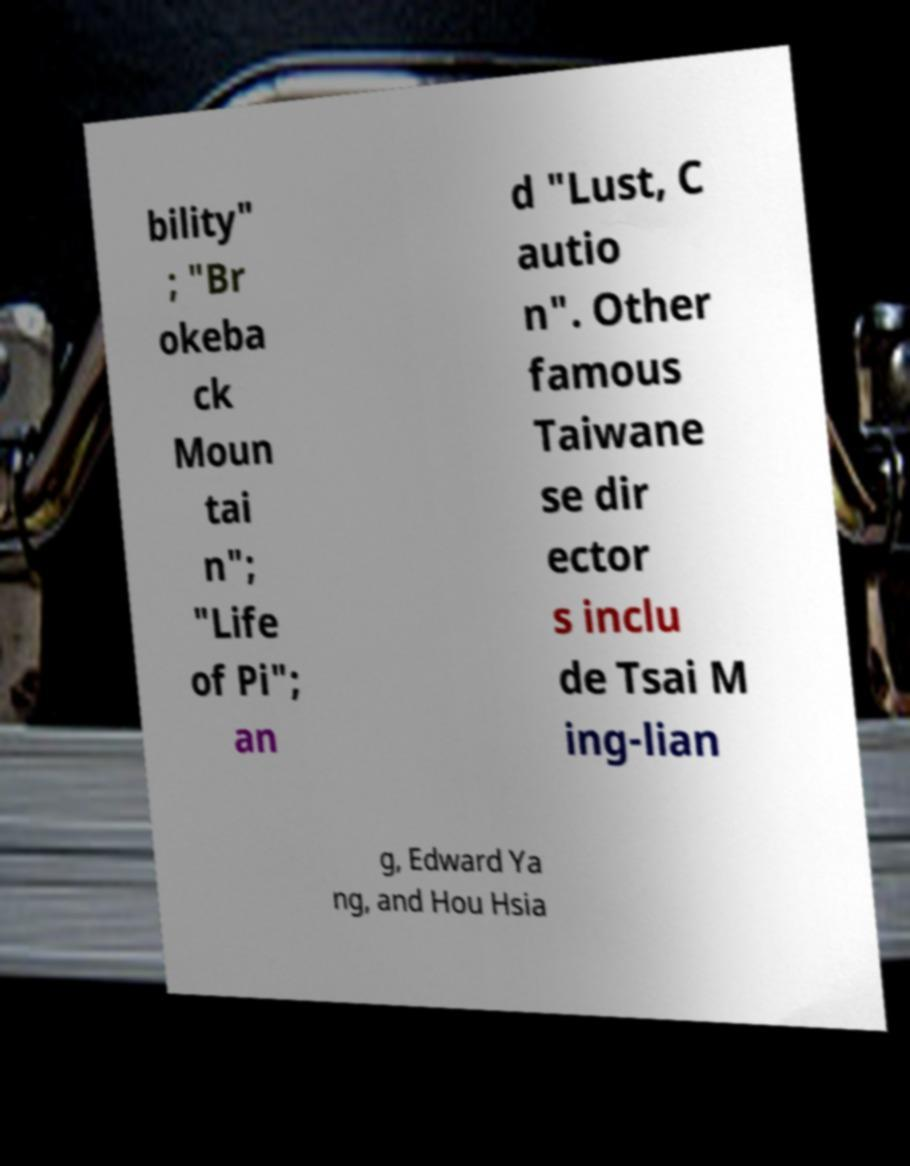Could you assist in decoding the text presented in this image and type it out clearly? bility" ; "Br okeba ck Moun tai n"; "Life of Pi"; an d "Lust, C autio n". Other famous Taiwane se dir ector s inclu de Tsai M ing-lian g, Edward Ya ng, and Hou Hsia 